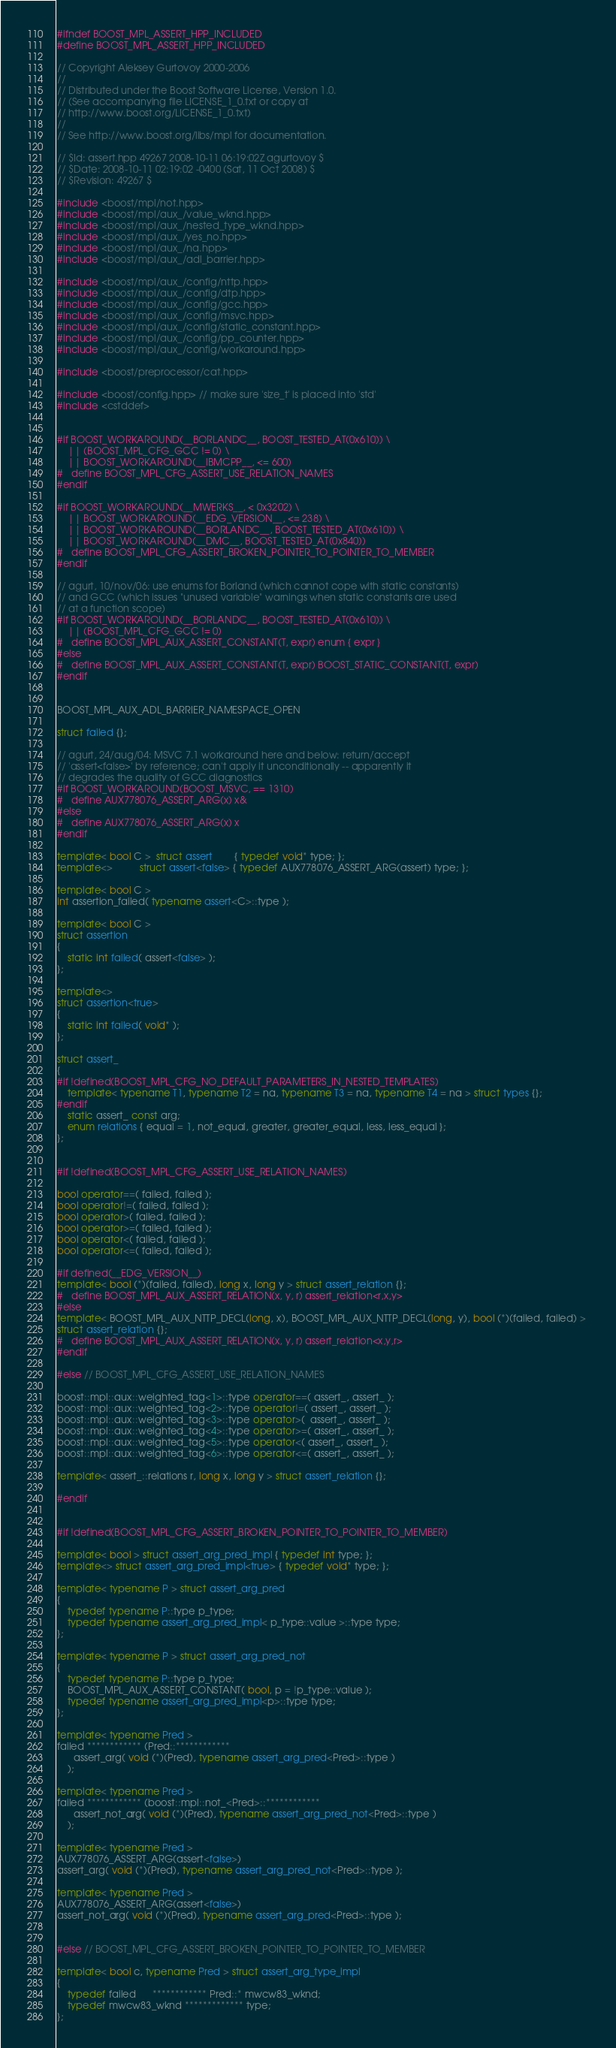Convert code to text. <code><loc_0><loc_0><loc_500><loc_500><_C++_>
#ifndef BOOST_MPL_ASSERT_HPP_INCLUDED
#define BOOST_MPL_ASSERT_HPP_INCLUDED

// Copyright Aleksey Gurtovoy 2000-2006
//
// Distributed under the Boost Software License, Version 1.0. 
// (See accompanying file LICENSE_1_0.txt or copy at 
// http://www.boost.org/LICENSE_1_0.txt)
//
// See http://www.boost.org/libs/mpl for documentation.

// $Id: assert.hpp 49267 2008-10-11 06:19:02Z agurtovoy $
// $Date: 2008-10-11 02:19:02 -0400 (Sat, 11 Oct 2008) $
// $Revision: 49267 $

#include <boost/mpl/not.hpp>
#include <boost/mpl/aux_/value_wknd.hpp>
#include <boost/mpl/aux_/nested_type_wknd.hpp>
#include <boost/mpl/aux_/yes_no.hpp>
#include <boost/mpl/aux_/na.hpp>
#include <boost/mpl/aux_/adl_barrier.hpp>

#include <boost/mpl/aux_/config/nttp.hpp>
#include <boost/mpl/aux_/config/dtp.hpp>
#include <boost/mpl/aux_/config/gcc.hpp>
#include <boost/mpl/aux_/config/msvc.hpp>
#include <boost/mpl/aux_/config/static_constant.hpp>
#include <boost/mpl/aux_/config/pp_counter.hpp>
#include <boost/mpl/aux_/config/workaround.hpp>

#include <boost/preprocessor/cat.hpp>

#include <boost/config.hpp> // make sure 'size_t' is placed into 'std'
#include <cstddef>


#if BOOST_WORKAROUND(__BORLANDC__, BOOST_TESTED_AT(0x610)) \
    || (BOOST_MPL_CFG_GCC != 0) \
    || BOOST_WORKAROUND(__IBMCPP__, <= 600)
#   define BOOST_MPL_CFG_ASSERT_USE_RELATION_NAMES
#endif

#if BOOST_WORKAROUND(__MWERKS__, < 0x3202) \
    || BOOST_WORKAROUND(__EDG_VERSION__, <= 238) \
    || BOOST_WORKAROUND(__BORLANDC__, BOOST_TESTED_AT(0x610)) \
    || BOOST_WORKAROUND(__DMC__, BOOST_TESTED_AT(0x840))
#   define BOOST_MPL_CFG_ASSERT_BROKEN_POINTER_TO_POINTER_TO_MEMBER
#endif

// agurt, 10/nov/06: use enums for Borland (which cannot cope with static constants) 
// and GCC (which issues "unused variable" warnings when static constants are used 
// at a function scope)
#if BOOST_WORKAROUND(__BORLANDC__, BOOST_TESTED_AT(0x610)) \
    || (BOOST_MPL_CFG_GCC != 0)
#   define BOOST_MPL_AUX_ASSERT_CONSTANT(T, expr) enum { expr }
#else
#   define BOOST_MPL_AUX_ASSERT_CONSTANT(T, expr) BOOST_STATIC_CONSTANT(T, expr)
#endif


BOOST_MPL_AUX_ADL_BARRIER_NAMESPACE_OPEN

struct failed {};

// agurt, 24/aug/04: MSVC 7.1 workaround here and below: return/accept 
// 'assert<false>' by reference; can't apply it unconditionally -- apparently it
// degrades the quality of GCC diagnostics
#if BOOST_WORKAROUND(BOOST_MSVC, == 1310)
#   define AUX778076_ASSERT_ARG(x) x&
#else
#   define AUX778076_ASSERT_ARG(x) x
#endif

template< bool C >  struct assert        { typedef void* type; };
template<>          struct assert<false> { typedef AUX778076_ASSERT_ARG(assert) type; };

template< bool C >
int assertion_failed( typename assert<C>::type );

template< bool C >
struct assertion
{
    static int failed( assert<false> );
};

template<>
struct assertion<true>
{
    static int failed( void* );
};

struct assert_
{
#if !defined(BOOST_MPL_CFG_NO_DEFAULT_PARAMETERS_IN_NESTED_TEMPLATES)
    template< typename T1, typename T2 = na, typename T3 = na, typename T4 = na > struct types {};
#endif
    static assert_ const arg;
    enum relations { equal = 1, not_equal, greater, greater_equal, less, less_equal };
};


#if !defined(BOOST_MPL_CFG_ASSERT_USE_RELATION_NAMES)

bool operator==( failed, failed );
bool operator!=( failed, failed );
bool operator>( failed, failed );
bool operator>=( failed, failed );
bool operator<( failed, failed );
bool operator<=( failed, failed );

#if defined(__EDG_VERSION__)
template< bool (*)(failed, failed), long x, long y > struct assert_relation {};
#   define BOOST_MPL_AUX_ASSERT_RELATION(x, y, r) assert_relation<r,x,y>
#else
template< BOOST_MPL_AUX_NTTP_DECL(long, x), BOOST_MPL_AUX_NTTP_DECL(long, y), bool (*)(failed, failed) > 
struct assert_relation {};
#   define BOOST_MPL_AUX_ASSERT_RELATION(x, y, r) assert_relation<x,y,r>
#endif

#else // BOOST_MPL_CFG_ASSERT_USE_RELATION_NAMES

boost::mpl::aux::weighted_tag<1>::type operator==( assert_, assert_ );
boost::mpl::aux::weighted_tag<2>::type operator!=( assert_, assert_ );
boost::mpl::aux::weighted_tag<3>::type operator>(  assert_, assert_ );
boost::mpl::aux::weighted_tag<4>::type operator>=( assert_, assert_ );
boost::mpl::aux::weighted_tag<5>::type operator<( assert_, assert_ );
boost::mpl::aux::weighted_tag<6>::type operator<=( assert_, assert_ );

template< assert_::relations r, long x, long y > struct assert_relation {};

#endif 


#if !defined(BOOST_MPL_CFG_ASSERT_BROKEN_POINTER_TO_POINTER_TO_MEMBER)

template< bool > struct assert_arg_pred_impl { typedef int type; };
template<> struct assert_arg_pred_impl<true> { typedef void* type; };

template< typename P > struct assert_arg_pred
{
    typedef typename P::type p_type;
    typedef typename assert_arg_pred_impl< p_type::value >::type type;
};

template< typename P > struct assert_arg_pred_not
{
    typedef typename P::type p_type;
    BOOST_MPL_AUX_ASSERT_CONSTANT( bool, p = !p_type::value );
    typedef typename assert_arg_pred_impl<p>::type type;
};

template< typename Pred >
failed ************ (Pred::************ 
      assert_arg( void (*)(Pred), typename assert_arg_pred<Pred>::type )
    );

template< typename Pred >
failed ************ (boost::mpl::not_<Pred>::************ 
      assert_not_arg( void (*)(Pred), typename assert_arg_pred_not<Pred>::type )
    );

template< typename Pred >
AUX778076_ASSERT_ARG(assert<false>)
assert_arg( void (*)(Pred), typename assert_arg_pred_not<Pred>::type );

template< typename Pred >
AUX778076_ASSERT_ARG(assert<false>)
assert_not_arg( void (*)(Pred), typename assert_arg_pred<Pred>::type );


#else // BOOST_MPL_CFG_ASSERT_BROKEN_POINTER_TO_POINTER_TO_MEMBER
        
template< bool c, typename Pred > struct assert_arg_type_impl
{
    typedef failed      ************ Pred::* mwcw83_wknd;
    typedef mwcw83_wknd ************* type;
};
</code> 